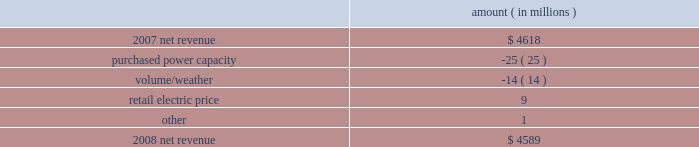Entergy corporation and subsidiaries management's financial discussion and analysis the expenses related to the voluntary severance program offered to employees .
Approximately 200 employees from the non-utility nuclear business and 150 employees in the utility business accepted the voluntary severance program offers .
Net revenue utility following is an analysis of the change in net revenue comparing 2008 to 2007 .
Amount ( in millions ) .
The purchased power capacity variance is primarily due to higher capacity charges .
A portion of the variance is due to the amortization of deferred capacity costs and is offset in base revenues due to base rate increases implemented to recover incremental deferred and ongoing purchased power capacity charges .
The volume/weather variance is primarily due to the effect of less favorable weather compared to the same period in 2007 and decreased electricity usage primarily during the unbilled sales period .
Hurricane gustav and hurricane ike , which hit the utility's service territories in september 2008 , contributed an estimated $ 46 million to the decrease in electricity usage .
Industrial sales were also depressed by the continuing effects of the hurricanes and , especially in the latter part of the year , because of the overall decline of the economy , leading to lower usage in the latter part of the year affecting both the large customer industrial segment as well as small and mid-sized industrial customers .
The decreases in electricity usage were partially offset by an increase in residential and commercial customer electricity usage that occurred during the periods of the year not affected by the hurricanes .
The retail electric price variance is primarily due to : an increase in the attala power plant costs recovered through the power management rider by entergy mississippi .
The net income effect of this recovery is limited to a portion representing an allowed return on equity with the remainder offset by attala power plant costs in other operation and maintenance expenses , depreciation expenses , and taxes other than income taxes ; a storm damage rider that became effective in october 2007 at entergy mississippi ; and an energy efficiency rider that became effective in november 2007 at entergy arkansas .
The establishment of the storm damage rider and the energy efficiency rider results in an increase in rider revenue and a corresponding increase in other operation and maintenance expense with no impact on net income .
The retail electric price variance was partially offset by : the absence of interim storm recoveries through the formula rate plans at entergy louisiana and entergy gulf states louisiana which ceased upon the act 55 financing of storm costs in the third quarter 2008 ; and a credit passed on to customers as a result of the act 55 storm cost financings .
Refer to "liquidity and capital resources - hurricane katrina and hurricane rita" below and note 2 to the financial statements for a discussion of the interim recovery of storm costs and the act 55 storm cost financings. .
How much lower was net revenue in 2008 than 2007 ? ( in million $ )? 
Computations: (4618 - 4589)
Answer: 29.0. 